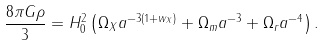Convert formula to latex. <formula><loc_0><loc_0><loc_500><loc_500>\frac { 8 \pi G \rho } { 3 } = H ^ { 2 } _ { 0 } \left ( \Omega _ { X } a ^ { - 3 ( 1 + w _ { X } ) } + \Omega _ { m } a ^ { - 3 } + \Omega _ { r } a ^ { - 4 } \right ) .</formula> 